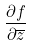<formula> <loc_0><loc_0><loc_500><loc_500>\frac { \partial f } { \partial \overline { z } }</formula> 